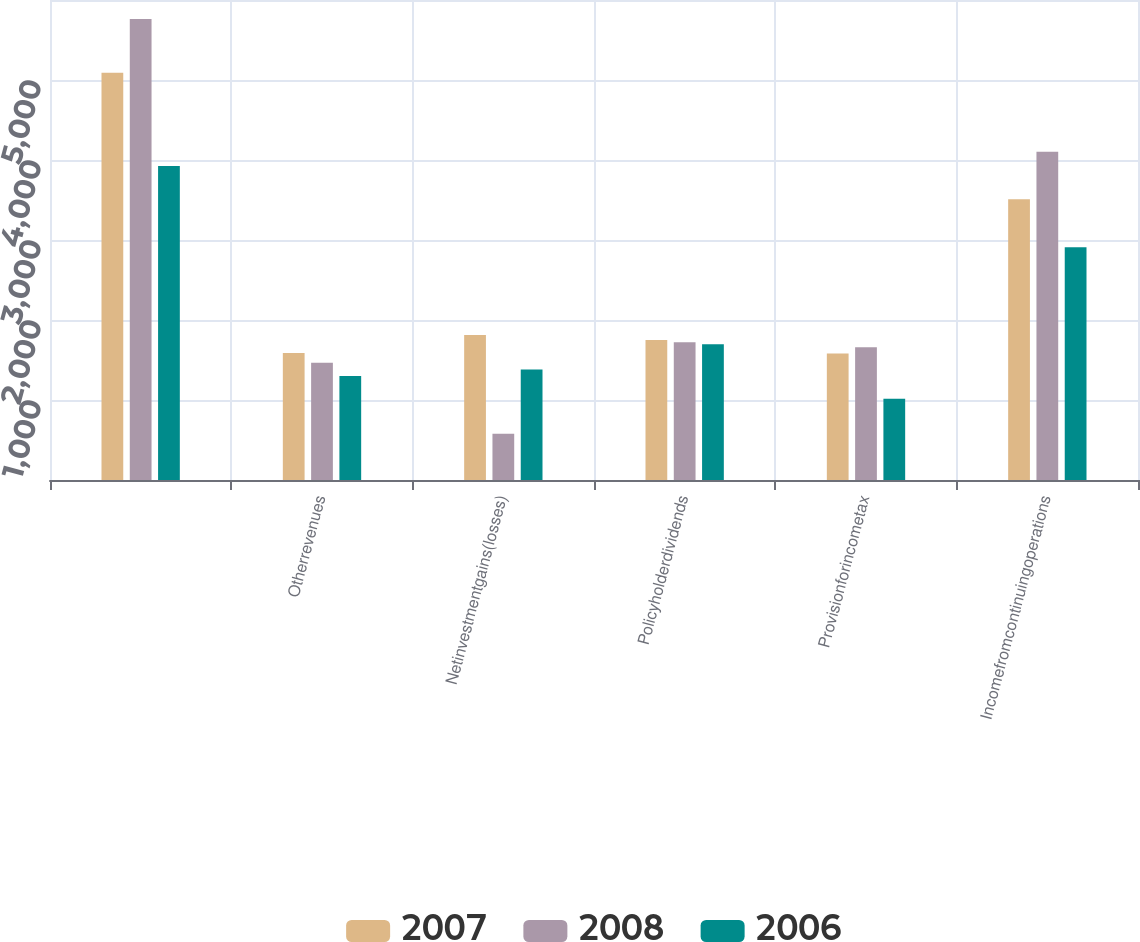Convert chart to OTSL. <chart><loc_0><loc_0><loc_500><loc_500><stacked_bar_chart><ecel><fcel>Unnamed: 1<fcel>Otherrevenues<fcel>Netinvestmentgains(losses)<fcel>Policyholderdividends<fcel>Provisionforincometax<fcel>Incomefromcontinuingoperations<nl><fcel>2007<fcel>5090<fcel>1586<fcel>1812<fcel>1751<fcel>1580<fcel>3510<nl><fcel>2008<fcel>5762<fcel>1465<fcel>578<fcel>1723<fcel>1660<fcel>4102<nl><fcel>2006<fcel>3926<fcel>1301<fcel>1382<fcel>1698<fcel>1016<fcel>2910<nl></chart> 